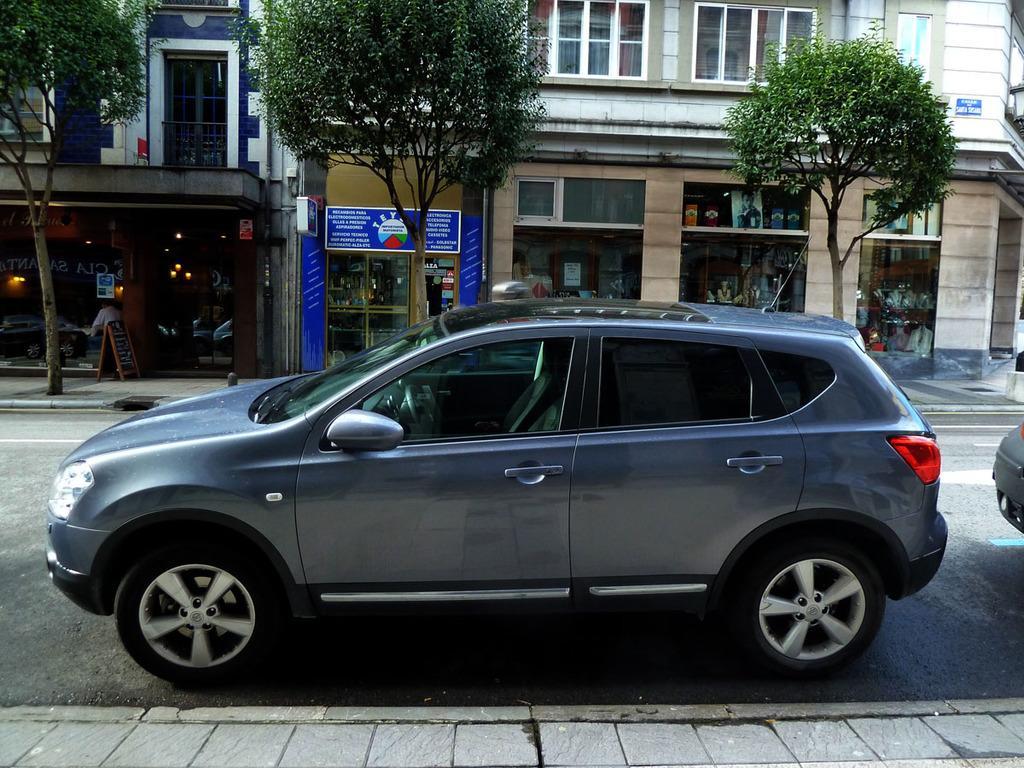Please provide a concise description of this image. Here we can see a vehicle on the road and at the bottom there is a footpath. In the background there are buildings,trees,glass doors,hoardings,windows,a person is sitting on a chair,lights and through the glass doors we can see objects and on the right there is a truncated vehicle on the road. 